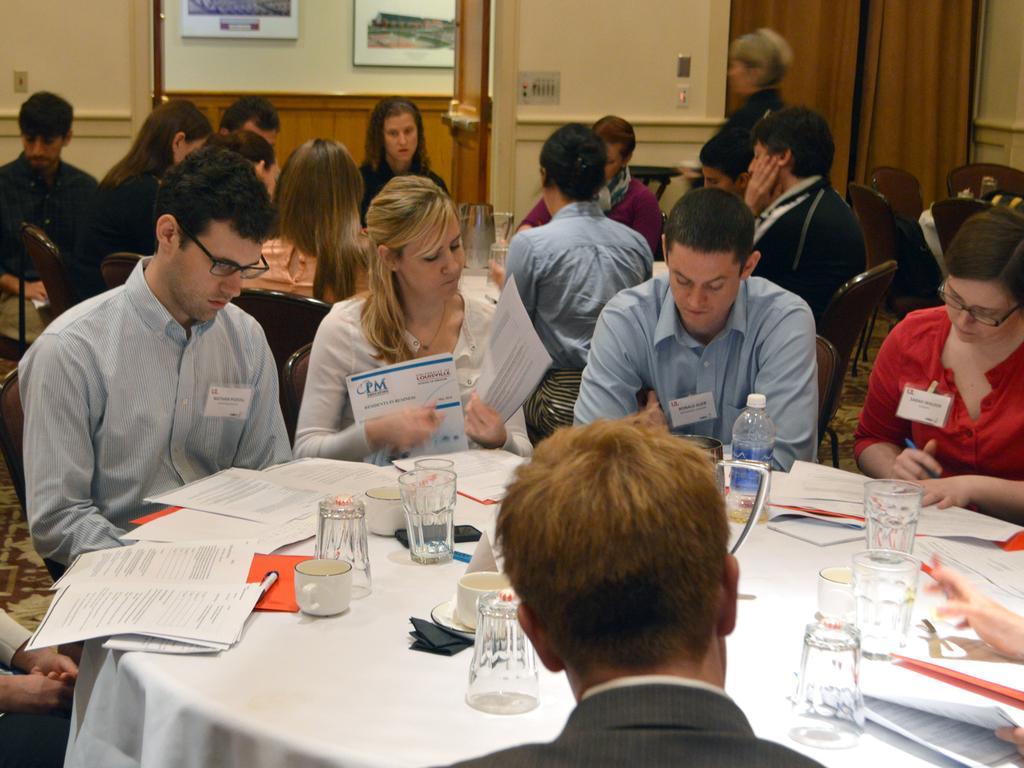Could you give a brief overview of what you see in this image? There are people sitting on chairs and we can see tables,on this table we can see glasses,bottle,cup,papers and objects. Background we can see wall,board and curtain. 